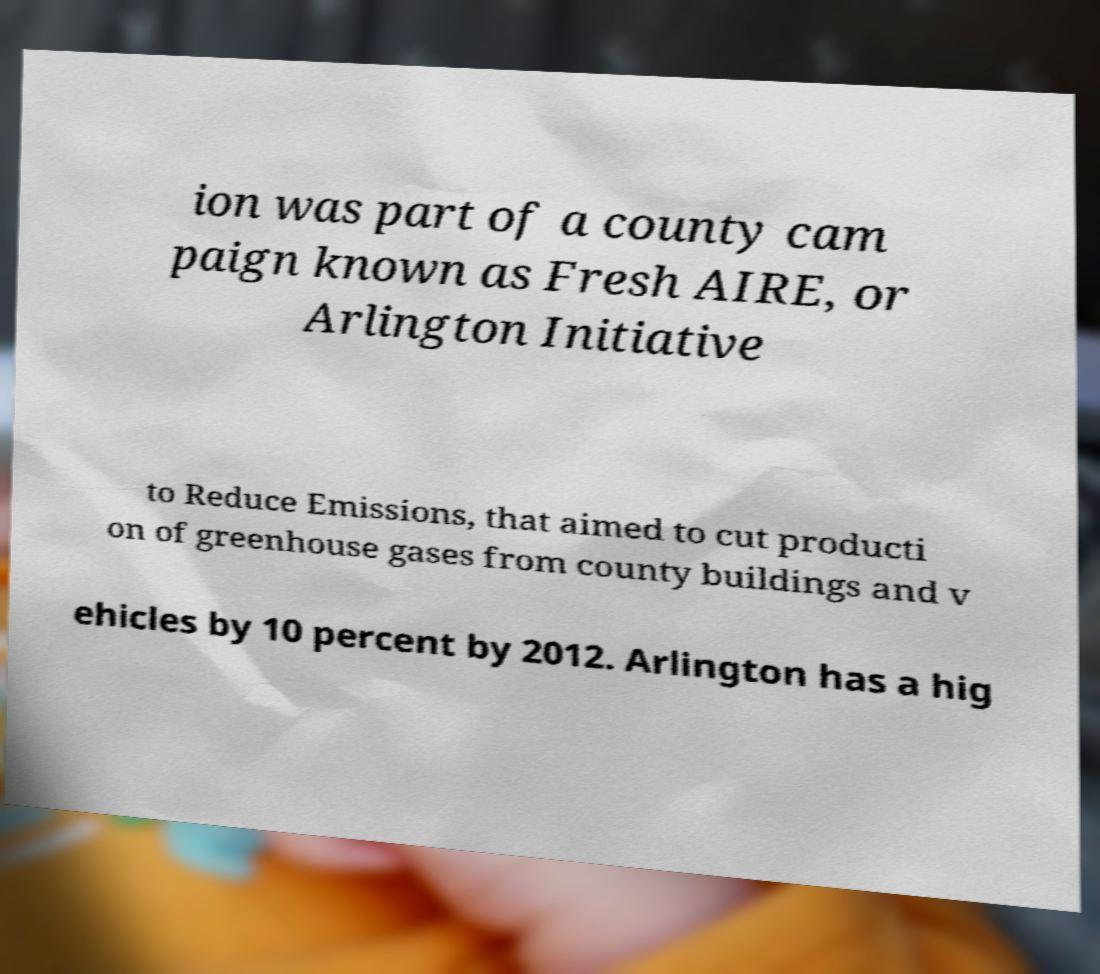Can you read and provide the text displayed in the image?This photo seems to have some interesting text. Can you extract and type it out for me? ion was part of a county cam paign known as Fresh AIRE, or Arlington Initiative to Reduce Emissions, that aimed to cut producti on of greenhouse gases from county buildings and v ehicles by 10 percent by 2012. Arlington has a hig 